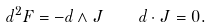<formula> <loc_0><loc_0><loc_500><loc_500>d ^ { 2 } F = - d \wedge J \quad d \cdot J = 0 .</formula> 